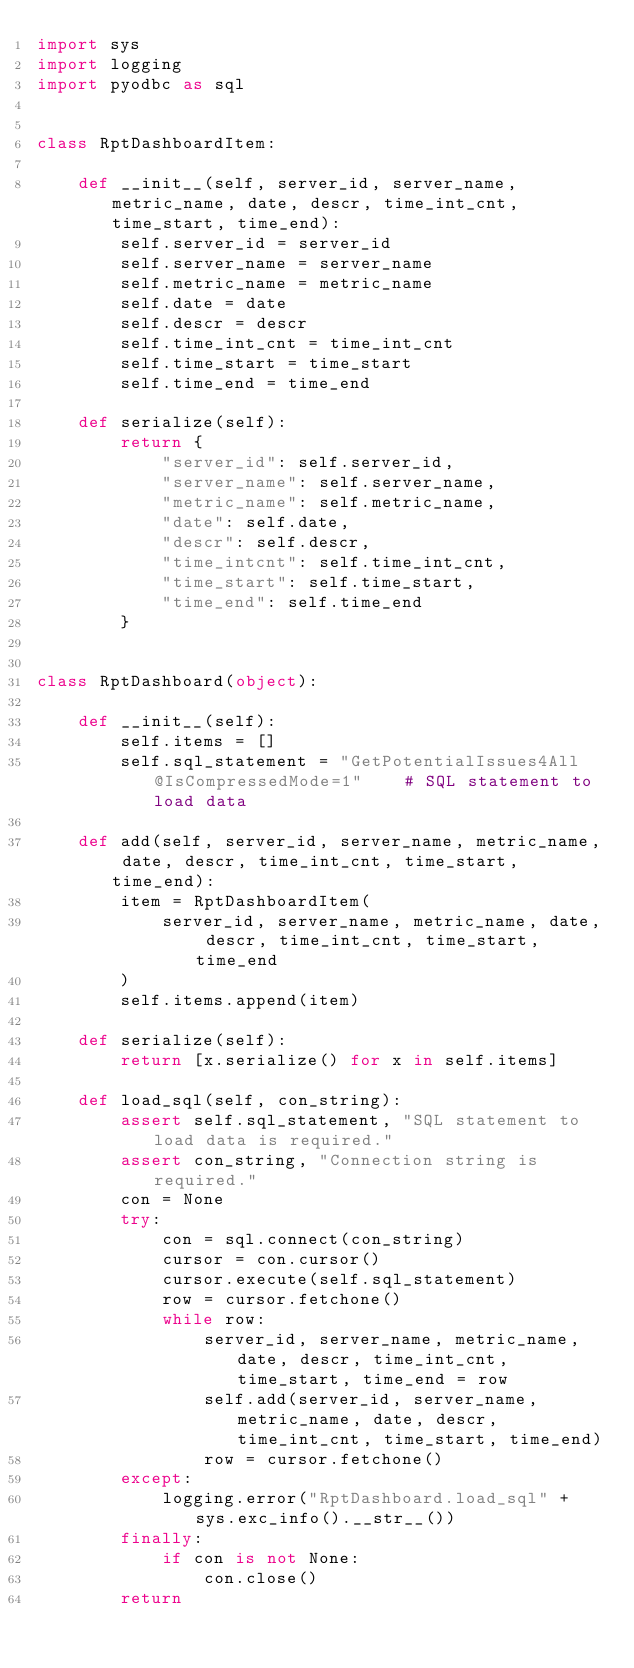Convert code to text. <code><loc_0><loc_0><loc_500><loc_500><_Python_>import sys
import logging
import pyodbc as sql


class RptDashboardItem:

    def __init__(self, server_id, server_name, metric_name, date, descr, time_int_cnt, time_start, time_end):
        self.server_id = server_id
        self.server_name = server_name
        self.metric_name = metric_name
        self.date = date
        self.descr = descr
        self.time_int_cnt = time_int_cnt
        self.time_start = time_start
        self.time_end = time_end

    def serialize(self):
        return {
            "server_id": self.server_id,
            "server_name": self.server_name,
            "metric_name": self.metric_name,
            "date": self.date,
            "descr": self.descr,
            "time_intcnt": self.time_int_cnt,
            "time_start": self.time_start,
            "time_end": self.time_end
        }


class RptDashboard(object):

    def __init__(self):
        self.items = []
        self.sql_statement = "GetPotentialIssues4All @IsCompressedMode=1"    # SQL statement to load data

    def add(self, server_id, server_name, metric_name, date, descr, time_int_cnt, time_start, time_end):
        item = RptDashboardItem(
            server_id, server_name, metric_name, date, descr, time_int_cnt, time_start, time_end
        )
        self.items.append(item)

    def serialize(self):
        return [x.serialize() for x in self.items]

    def load_sql(self, con_string):
        assert self.sql_statement, "SQL statement to load data is required."
        assert con_string, "Connection string is required."
        con = None
        try:
            con = sql.connect(con_string)
            cursor = con.cursor()
            cursor.execute(self.sql_statement)
            row = cursor.fetchone()
            while row:
                server_id, server_name, metric_name, date, descr, time_int_cnt, time_start, time_end = row
                self.add(server_id, server_name, metric_name, date, descr, time_int_cnt, time_start, time_end)
                row = cursor.fetchone()
        except:
            logging.error("RptDashboard.load_sql" + sys.exc_info().__str__())
        finally:
            if con is not None:
                con.close()
        return
</code> 